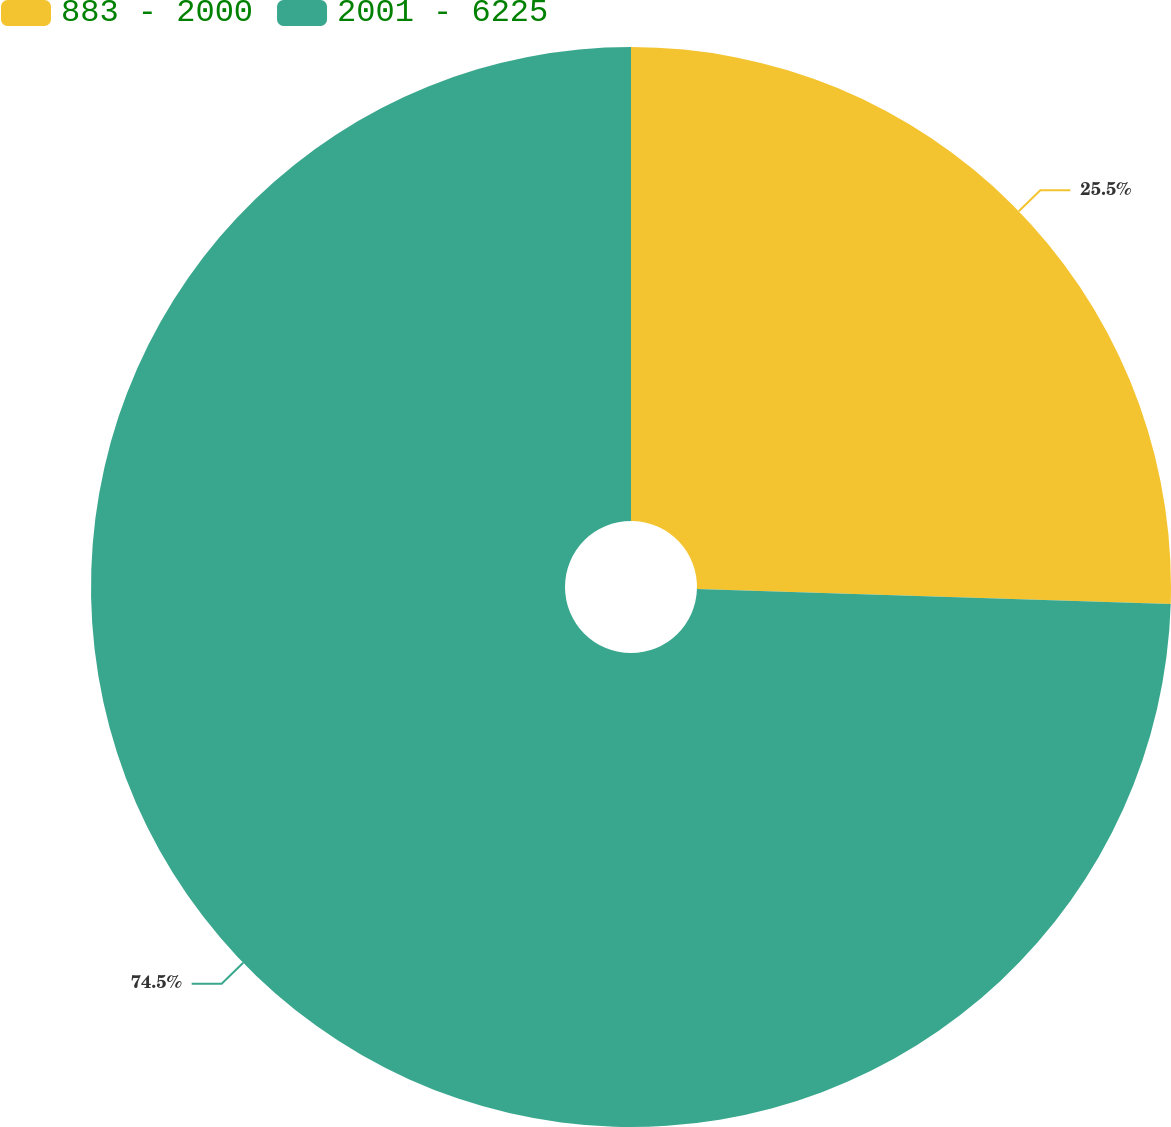<chart> <loc_0><loc_0><loc_500><loc_500><pie_chart><fcel>883 - 2000<fcel>2001 - 6225<nl><fcel>25.5%<fcel>74.5%<nl></chart> 